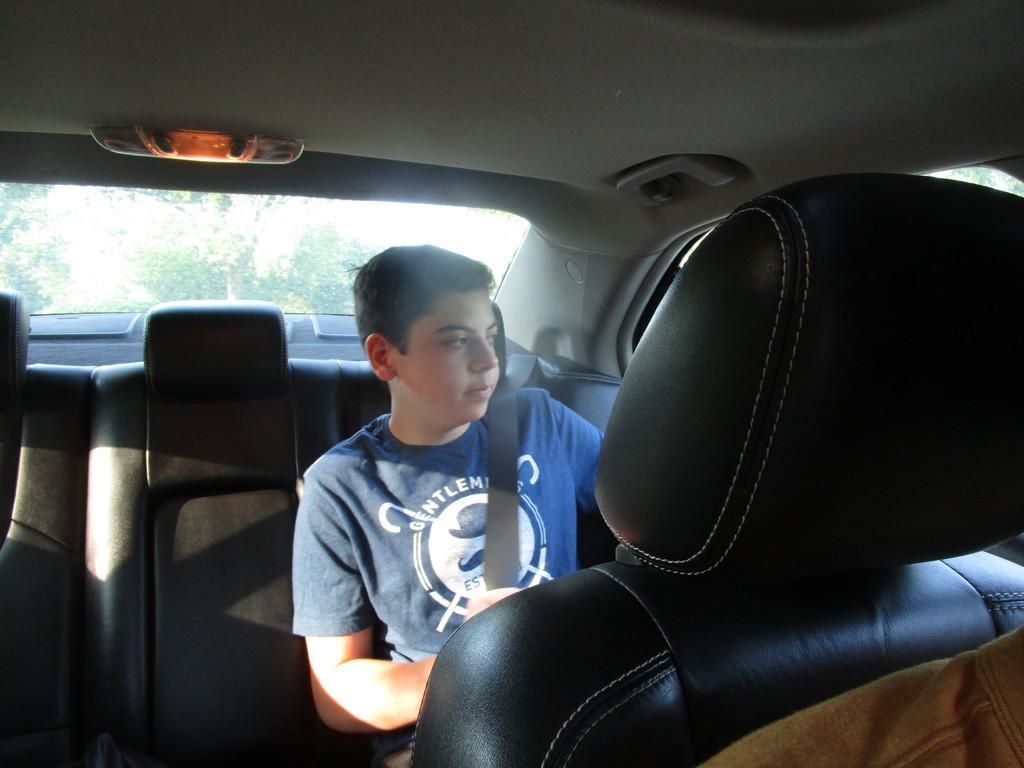How would you summarize this image in a sentence or two? This picture shows an inner view of a car. We see a man seated on the back and we see he wore a seat belt 